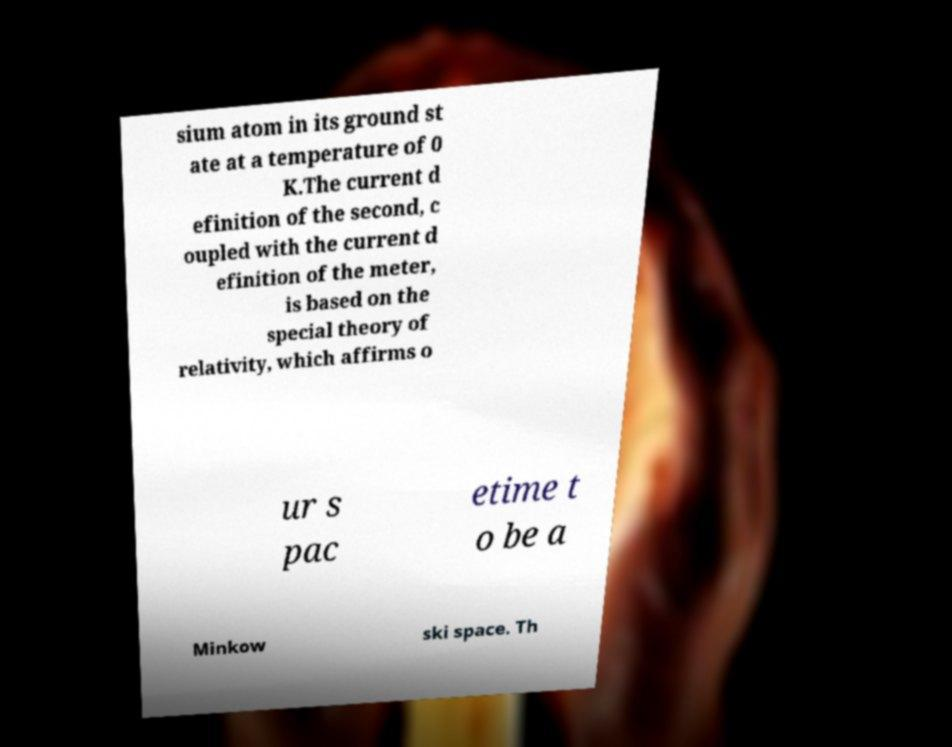I need the written content from this picture converted into text. Can you do that? sium atom in its ground st ate at a temperature of 0 K.The current d efinition of the second, c oupled with the current d efinition of the meter, is based on the special theory of relativity, which affirms o ur s pac etime t o be a Minkow ski space. Th 